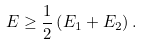<formula> <loc_0><loc_0><loc_500><loc_500>E \geq \frac { 1 } { 2 } \left ( E _ { 1 } + E _ { 2 } \right ) .</formula> 